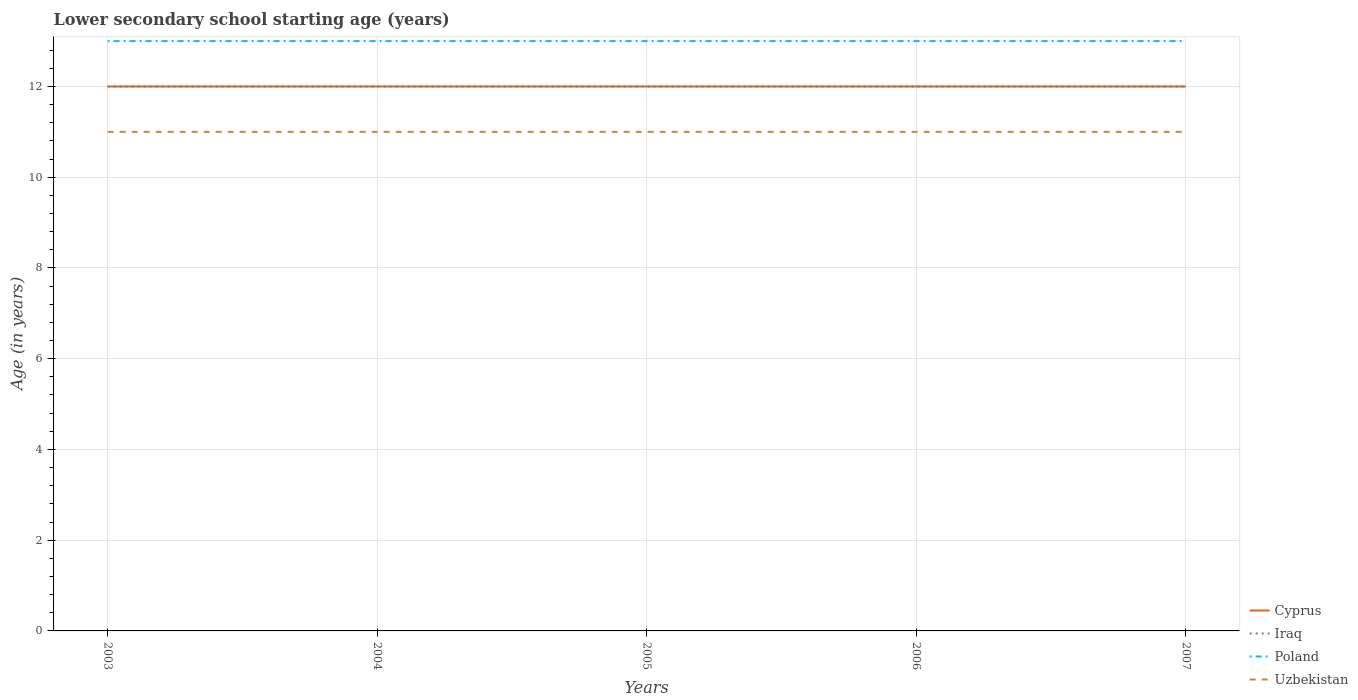Is the number of lines equal to the number of legend labels?
Provide a succinct answer. Yes. Across all years, what is the maximum lower secondary school starting age of children in Iraq?
Make the answer very short. 12. What is the difference between the highest and the second highest lower secondary school starting age of children in Uzbekistan?
Provide a short and direct response. 0. What is the difference between the highest and the lowest lower secondary school starting age of children in Uzbekistan?
Keep it short and to the point. 0. How many lines are there?
Your answer should be compact. 4. What is the difference between two consecutive major ticks on the Y-axis?
Keep it short and to the point. 2. Are the values on the major ticks of Y-axis written in scientific E-notation?
Make the answer very short. No. Does the graph contain any zero values?
Keep it short and to the point. No. How are the legend labels stacked?
Your answer should be very brief. Vertical. What is the title of the graph?
Provide a succinct answer. Lower secondary school starting age (years). What is the label or title of the Y-axis?
Offer a very short reply. Age (in years). What is the Age (in years) in Cyprus in 2003?
Ensure brevity in your answer.  12. What is the Age (in years) in Poland in 2003?
Your answer should be compact. 13. What is the Age (in years) of Cyprus in 2004?
Ensure brevity in your answer.  12. What is the Age (in years) in Iraq in 2004?
Ensure brevity in your answer.  12. What is the Age (in years) in Poland in 2004?
Your answer should be compact. 13. What is the Age (in years) of Uzbekistan in 2004?
Offer a terse response. 11. What is the Age (in years) of Cyprus in 2006?
Ensure brevity in your answer.  12. What is the Age (in years) of Iraq in 2006?
Make the answer very short. 12. What is the Age (in years) in Poland in 2006?
Offer a very short reply. 13. What is the Age (in years) of Cyprus in 2007?
Give a very brief answer. 12. What is the Age (in years) of Iraq in 2007?
Offer a very short reply. 12. What is the Age (in years) of Uzbekistan in 2007?
Your answer should be very brief. 11. Across all years, what is the maximum Age (in years) of Poland?
Offer a very short reply. 13. Across all years, what is the maximum Age (in years) of Uzbekistan?
Make the answer very short. 11. Across all years, what is the minimum Age (in years) in Uzbekistan?
Your answer should be compact. 11. What is the total Age (in years) of Cyprus in the graph?
Provide a short and direct response. 60. What is the total Age (in years) in Uzbekistan in the graph?
Offer a very short reply. 55. What is the difference between the Age (in years) of Iraq in 2003 and that in 2004?
Your response must be concise. 0. What is the difference between the Age (in years) in Poland in 2003 and that in 2004?
Give a very brief answer. 0. What is the difference between the Age (in years) in Cyprus in 2003 and that in 2005?
Your answer should be very brief. 0. What is the difference between the Age (in years) of Poland in 2003 and that in 2005?
Ensure brevity in your answer.  0. What is the difference between the Age (in years) in Uzbekistan in 2003 and that in 2005?
Make the answer very short. 0. What is the difference between the Age (in years) in Iraq in 2003 and that in 2006?
Ensure brevity in your answer.  0. What is the difference between the Age (in years) in Poland in 2003 and that in 2006?
Provide a short and direct response. 0. What is the difference between the Age (in years) of Uzbekistan in 2003 and that in 2006?
Ensure brevity in your answer.  0. What is the difference between the Age (in years) of Cyprus in 2003 and that in 2007?
Keep it short and to the point. 0. What is the difference between the Age (in years) in Poland in 2003 and that in 2007?
Keep it short and to the point. 0. What is the difference between the Age (in years) of Uzbekistan in 2003 and that in 2007?
Give a very brief answer. 0. What is the difference between the Age (in years) in Cyprus in 2004 and that in 2005?
Your response must be concise. 0. What is the difference between the Age (in years) in Iraq in 2004 and that in 2005?
Keep it short and to the point. 0. What is the difference between the Age (in years) of Poland in 2004 and that in 2005?
Provide a short and direct response. 0. What is the difference between the Age (in years) of Iraq in 2004 and that in 2006?
Make the answer very short. 0. What is the difference between the Age (in years) of Poland in 2004 and that in 2006?
Ensure brevity in your answer.  0. What is the difference between the Age (in years) of Uzbekistan in 2004 and that in 2006?
Keep it short and to the point. 0. What is the difference between the Age (in years) of Cyprus in 2004 and that in 2007?
Your answer should be very brief. 0. What is the difference between the Age (in years) in Poland in 2004 and that in 2007?
Offer a very short reply. 0. What is the difference between the Age (in years) in Uzbekistan in 2004 and that in 2007?
Keep it short and to the point. 0. What is the difference between the Age (in years) of Cyprus in 2005 and that in 2006?
Your answer should be very brief. 0. What is the difference between the Age (in years) in Poland in 2005 and that in 2006?
Make the answer very short. 0. What is the difference between the Age (in years) in Uzbekistan in 2005 and that in 2006?
Make the answer very short. 0. What is the difference between the Age (in years) of Cyprus in 2005 and that in 2007?
Provide a succinct answer. 0. What is the difference between the Age (in years) of Poland in 2005 and that in 2007?
Your response must be concise. 0. What is the difference between the Age (in years) of Cyprus in 2006 and that in 2007?
Give a very brief answer. 0. What is the difference between the Age (in years) of Uzbekistan in 2006 and that in 2007?
Keep it short and to the point. 0. What is the difference between the Age (in years) in Cyprus in 2003 and the Age (in years) in Uzbekistan in 2004?
Offer a terse response. 1. What is the difference between the Age (in years) of Iraq in 2003 and the Age (in years) of Uzbekistan in 2004?
Your answer should be very brief. 1. What is the difference between the Age (in years) of Cyprus in 2003 and the Age (in years) of Uzbekistan in 2005?
Your answer should be compact. 1. What is the difference between the Age (in years) in Iraq in 2003 and the Age (in years) in Uzbekistan in 2005?
Keep it short and to the point. 1. What is the difference between the Age (in years) in Poland in 2003 and the Age (in years) in Uzbekistan in 2005?
Your answer should be compact. 2. What is the difference between the Age (in years) of Cyprus in 2003 and the Age (in years) of Iraq in 2006?
Ensure brevity in your answer.  0. What is the difference between the Age (in years) of Iraq in 2003 and the Age (in years) of Uzbekistan in 2006?
Your answer should be compact. 1. What is the difference between the Age (in years) in Cyprus in 2003 and the Age (in years) in Iraq in 2007?
Make the answer very short. 0. What is the difference between the Age (in years) in Cyprus in 2003 and the Age (in years) in Uzbekistan in 2007?
Your response must be concise. 1. What is the difference between the Age (in years) in Iraq in 2003 and the Age (in years) in Uzbekistan in 2007?
Make the answer very short. 1. What is the difference between the Age (in years) in Poland in 2003 and the Age (in years) in Uzbekistan in 2007?
Offer a very short reply. 2. What is the difference between the Age (in years) of Cyprus in 2004 and the Age (in years) of Iraq in 2005?
Offer a terse response. 0. What is the difference between the Age (in years) in Cyprus in 2004 and the Age (in years) in Poland in 2005?
Provide a succinct answer. -1. What is the difference between the Age (in years) in Iraq in 2004 and the Age (in years) in Poland in 2006?
Your answer should be very brief. -1. What is the difference between the Age (in years) of Poland in 2004 and the Age (in years) of Uzbekistan in 2006?
Your answer should be compact. 2. What is the difference between the Age (in years) in Cyprus in 2004 and the Age (in years) in Iraq in 2007?
Your answer should be compact. 0. What is the difference between the Age (in years) of Cyprus in 2004 and the Age (in years) of Uzbekistan in 2007?
Give a very brief answer. 1. What is the difference between the Age (in years) in Iraq in 2004 and the Age (in years) in Uzbekistan in 2007?
Offer a terse response. 1. What is the difference between the Age (in years) of Poland in 2005 and the Age (in years) of Uzbekistan in 2006?
Keep it short and to the point. 2. What is the difference between the Age (in years) of Cyprus in 2005 and the Age (in years) of Iraq in 2007?
Ensure brevity in your answer.  0. What is the difference between the Age (in years) of Cyprus in 2005 and the Age (in years) of Uzbekistan in 2007?
Your response must be concise. 1. What is the difference between the Age (in years) of Iraq in 2005 and the Age (in years) of Poland in 2007?
Provide a short and direct response. -1. What is the difference between the Age (in years) in Iraq in 2005 and the Age (in years) in Uzbekistan in 2007?
Your answer should be compact. 1. What is the difference between the Age (in years) in Cyprus in 2006 and the Age (in years) in Iraq in 2007?
Make the answer very short. 0. What is the difference between the Age (in years) in Iraq in 2006 and the Age (in years) in Poland in 2007?
Provide a succinct answer. -1. What is the average Age (in years) of Cyprus per year?
Make the answer very short. 12. What is the average Age (in years) of Uzbekistan per year?
Your answer should be very brief. 11. In the year 2003, what is the difference between the Age (in years) in Cyprus and Age (in years) in Iraq?
Make the answer very short. 0. In the year 2003, what is the difference between the Age (in years) in Cyprus and Age (in years) in Poland?
Your answer should be very brief. -1. In the year 2003, what is the difference between the Age (in years) of Iraq and Age (in years) of Uzbekistan?
Make the answer very short. 1. In the year 2004, what is the difference between the Age (in years) of Poland and Age (in years) of Uzbekistan?
Your answer should be compact. 2. In the year 2005, what is the difference between the Age (in years) of Cyprus and Age (in years) of Iraq?
Keep it short and to the point. 0. In the year 2005, what is the difference between the Age (in years) in Cyprus and Age (in years) in Poland?
Provide a short and direct response. -1. In the year 2005, what is the difference between the Age (in years) of Poland and Age (in years) of Uzbekistan?
Offer a very short reply. 2. In the year 2006, what is the difference between the Age (in years) in Cyprus and Age (in years) in Iraq?
Provide a short and direct response. 0. In the year 2006, what is the difference between the Age (in years) of Cyprus and Age (in years) of Uzbekistan?
Provide a succinct answer. 1. In the year 2006, what is the difference between the Age (in years) in Iraq and Age (in years) in Poland?
Make the answer very short. -1. In the year 2007, what is the difference between the Age (in years) in Cyprus and Age (in years) in Iraq?
Ensure brevity in your answer.  0. In the year 2007, what is the difference between the Age (in years) in Iraq and Age (in years) in Poland?
Ensure brevity in your answer.  -1. In the year 2007, what is the difference between the Age (in years) in Poland and Age (in years) in Uzbekistan?
Offer a very short reply. 2. What is the ratio of the Age (in years) in Cyprus in 2003 to that in 2004?
Provide a succinct answer. 1. What is the ratio of the Age (in years) in Iraq in 2003 to that in 2004?
Offer a very short reply. 1. What is the ratio of the Age (in years) of Uzbekistan in 2003 to that in 2004?
Offer a terse response. 1. What is the ratio of the Age (in years) of Iraq in 2003 to that in 2005?
Give a very brief answer. 1. What is the ratio of the Age (in years) in Poland in 2003 to that in 2005?
Keep it short and to the point. 1. What is the ratio of the Age (in years) of Iraq in 2003 to that in 2006?
Offer a terse response. 1. What is the ratio of the Age (in years) of Poland in 2003 to that in 2006?
Ensure brevity in your answer.  1. What is the ratio of the Age (in years) in Uzbekistan in 2003 to that in 2006?
Provide a short and direct response. 1. What is the ratio of the Age (in years) of Cyprus in 2003 to that in 2007?
Provide a short and direct response. 1. What is the ratio of the Age (in years) of Iraq in 2003 to that in 2007?
Ensure brevity in your answer.  1. What is the ratio of the Age (in years) of Poland in 2003 to that in 2007?
Provide a succinct answer. 1. What is the ratio of the Age (in years) in Cyprus in 2004 to that in 2005?
Make the answer very short. 1. What is the ratio of the Age (in years) in Uzbekistan in 2004 to that in 2005?
Make the answer very short. 1. What is the ratio of the Age (in years) of Iraq in 2004 to that in 2006?
Your answer should be very brief. 1. What is the ratio of the Age (in years) in Uzbekistan in 2004 to that in 2006?
Make the answer very short. 1. What is the ratio of the Age (in years) of Cyprus in 2004 to that in 2007?
Your response must be concise. 1. What is the ratio of the Age (in years) of Cyprus in 2005 to that in 2006?
Give a very brief answer. 1. What is the ratio of the Age (in years) of Poland in 2005 to that in 2006?
Your response must be concise. 1. What is the ratio of the Age (in years) of Cyprus in 2005 to that in 2007?
Keep it short and to the point. 1. What is the ratio of the Age (in years) in Iraq in 2005 to that in 2007?
Your response must be concise. 1. What is the ratio of the Age (in years) of Poland in 2005 to that in 2007?
Your answer should be very brief. 1. What is the ratio of the Age (in years) in Uzbekistan in 2005 to that in 2007?
Provide a short and direct response. 1. What is the ratio of the Age (in years) of Iraq in 2006 to that in 2007?
Keep it short and to the point. 1. What is the difference between the highest and the second highest Age (in years) in Cyprus?
Ensure brevity in your answer.  0. What is the difference between the highest and the second highest Age (in years) in Iraq?
Provide a succinct answer. 0. What is the difference between the highest and the second highest Age (in years) in Uzbekistan?
Offer a very short reply. 0. What is the difference between the highest and the lowest Age (in years) of Poland?
Keep it short and to the point. 0. What is the difference between the highest and the lowest Age (in years) in Uzbekistan?
Provide a short and direct response. 0. 